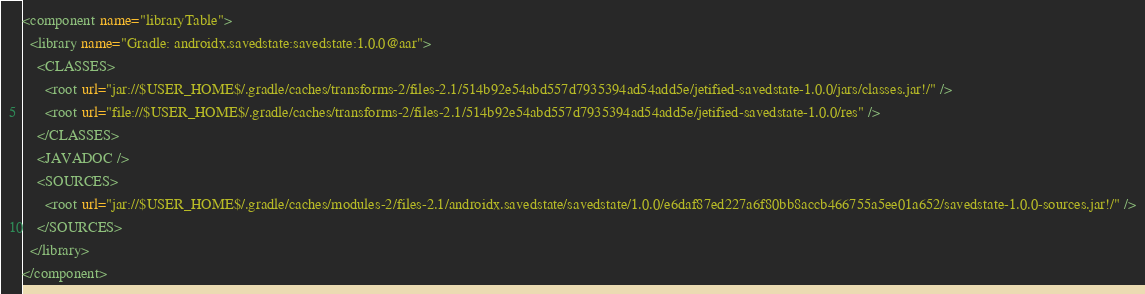Convert code to text. <code><loc_0><loc_0><loc_500><loc_500><_XML_><component name="libraryTable">
  <library name="Gradle: androidx.savedstate:savedstate:1.0.0@aar">
    <CLASSES>
      <root url="jar://$USER_HOME$/.gradle/caches/transforms-2/files-2.1/514b92e54abd557d7935394ad54add5e/jetified-savedstate-1.0.0/jars/classes.jar!/" />
      <root url="file://$USER_HOME$/.gradle/caches/transforms-2/files-2.1/514b92e54abd557d7935394ad54add5e/jetified-savedstate-1.0.0/res" />
    </CLASSES>
    <JAVADOC />
    <SOURCES>
      <root url="jar://$USER_HOME$/.gradle/caches/modules-2/files-2.1/androidx.savedstate/savedstate/1.0.0/e6daf87ed227a6f80bb8accb466755a5ee01a652/savedstate-1.0.0-sources.jar!/" />
    </SOURCES>
  </library>
</component></code> 